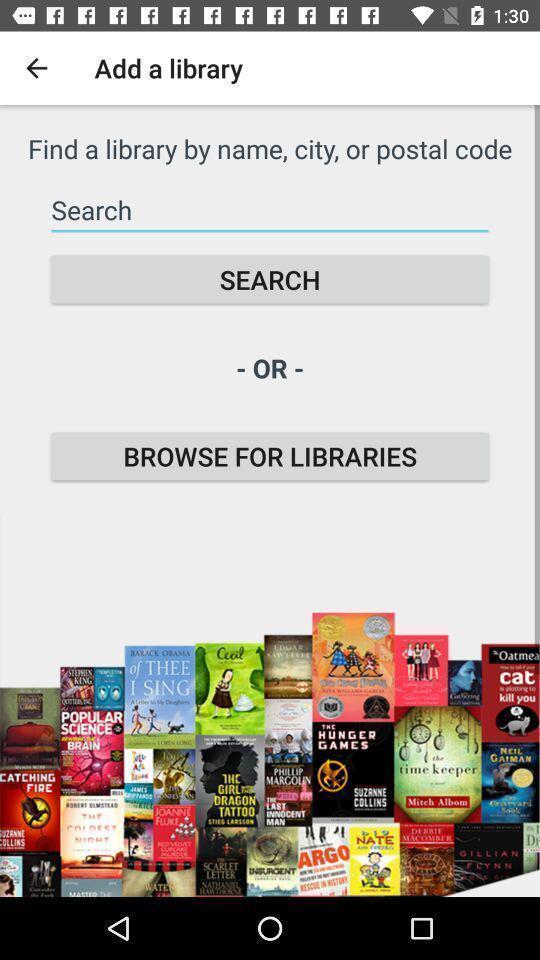Explain what's happening in this screen capture. Screen showing search bar to find libraries. 